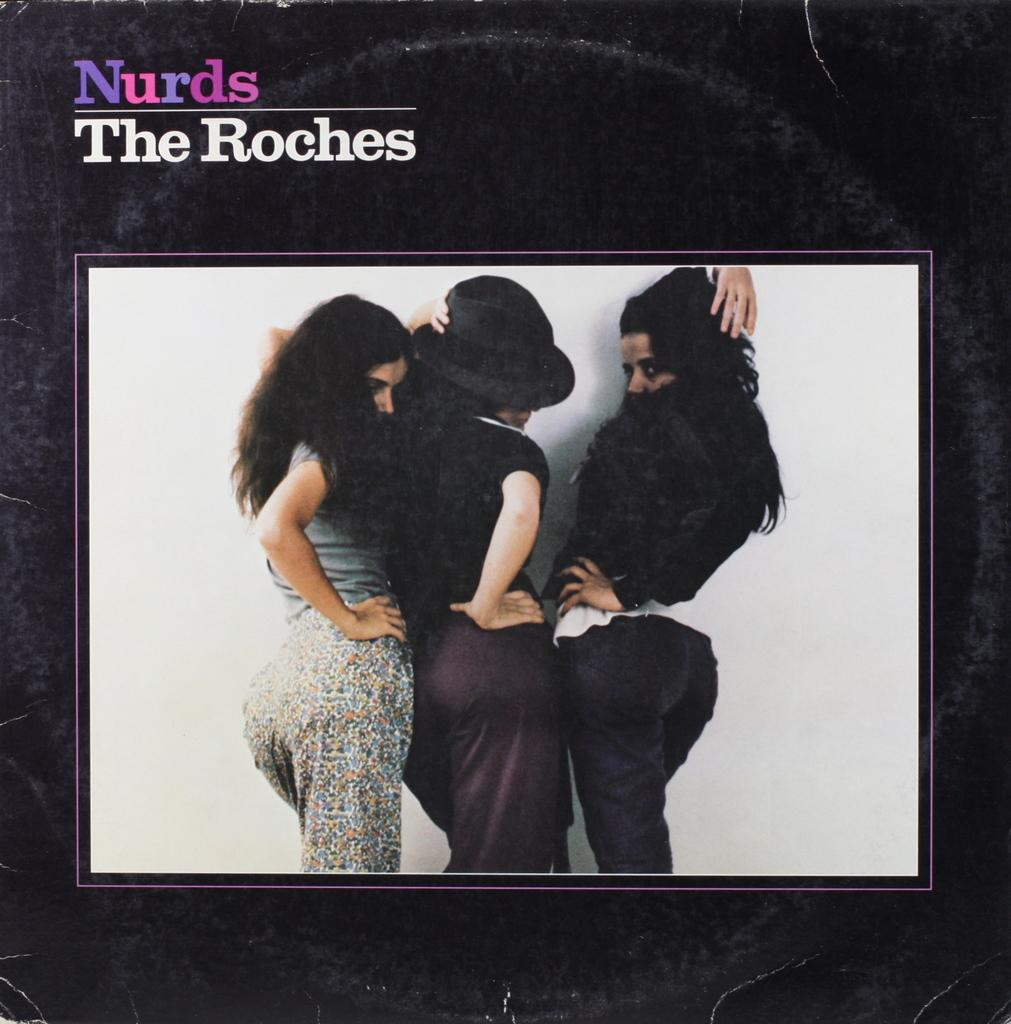What is the main subject of the image? There is a picture of a woman in the image. How is the woman positioned in the image? The woman is standing with the support of a wall. What else can be seen on the image besides the woman? There is text on the outer surface of the image. What type of pain is the woman experiencing in the image? There is no indication of pain in the image; the woman is simply standing with the support of a wall. What historical event is depicted in the image? The image does not depict any historical event; it features a woman standing with the support of a wall and text on the outer surface. 